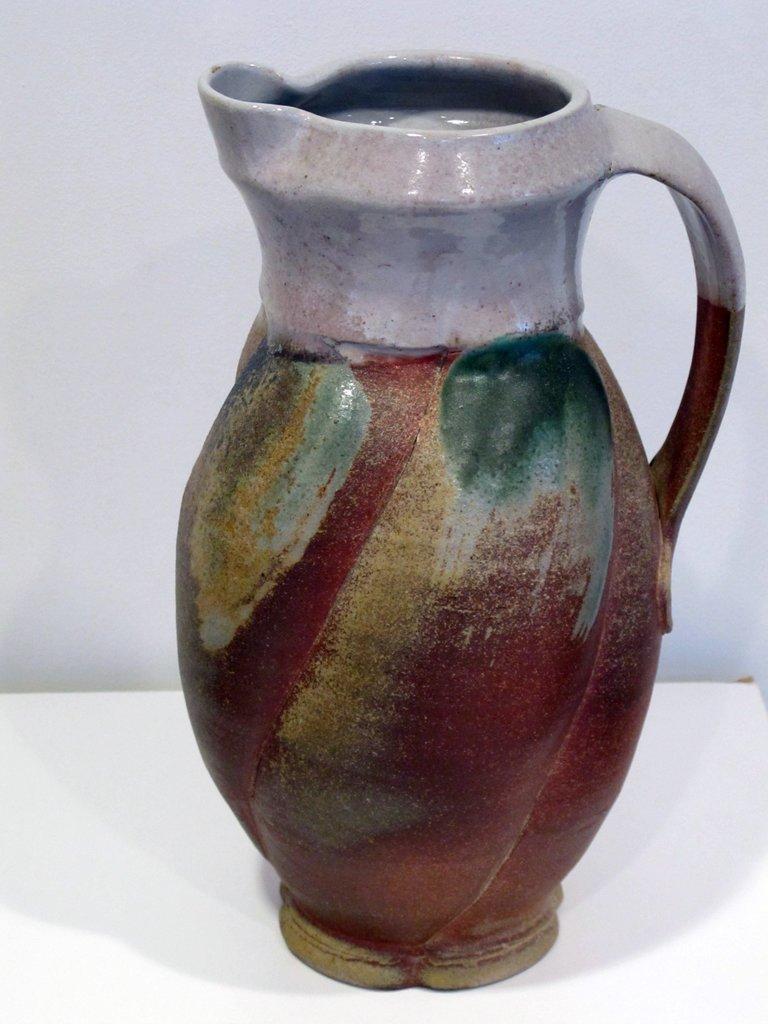Could you give a brief overview of what you see in this image? In this picture there is a flower vase which is in brown and ash color. 